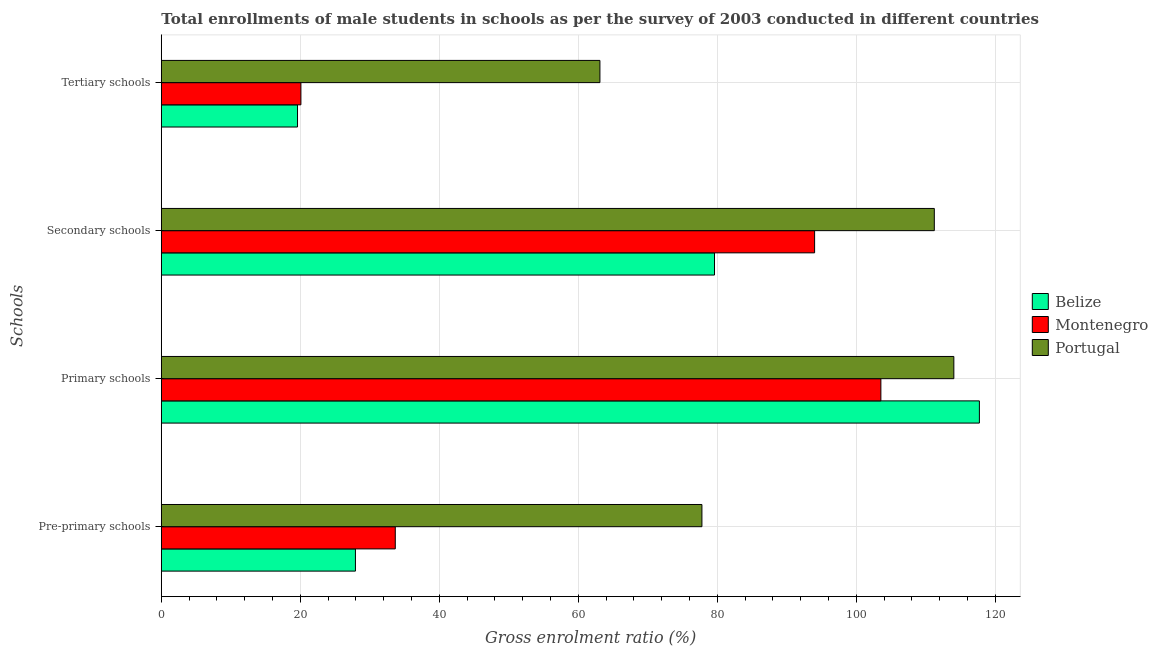Are the number of bars per tick equal to the number of legend labels?
Keep it short and to the point. Yes. How many bars are there on the 3rd tick from the bottom?
Provide a succinct answer. 3. What is the label of the 1st group of bars from the top?
Make the answer very short. Tertiary schools. What is the gross enrolment ratio(male) in pre-primary schools in Montenegro?
Your answer should be very brief. 33.67. Across all countries, what is the maximum gross enrolment ratio(male) in secondary schools?
Provide a succinct answer. 111.24. Across all countries, what is the minimum gross enrolment ratio(male) in primary schools?
Your answer should be compact. 103.55. In which country was the gross enrolment ratio(male) in pre-primary schools minimum?
Your answer should be compact. Belize. What is the total gross enrolment ratio(male) in tertiary schools in the graph?
Ensure brevity in your answer.  102.8. What is the difference between the gross enrolment ratio(male) in secondary schools in Portugal and that in Montenegro?
Your answer should be very brief. 17.22. What is the difference between the gross enrolment ratio(male) in pre-primary schools in Belize and the gross enrolment ratio(male) in primary schools in Montenegro?
Offer a terse response. -75.61. What is the average gross enrolment ratio(male) in secondary schools per country?
Your answer should be compact. 94.95. What is the difference between the gross enrolment ratio(male) in primary schools and gross enrolment ratio(male) in secondary schools in Montenegro?
Provide a succinct answer. 9.54. What is the ratio of the gross enrolment ratio(male) in secondary schools in Belize to that in Montenegro?
Make the answer very short. 0.85. Is the gross enrolment ratio(male) in primary schools in Portugal less than that in Belize?
Your answer should be very brief. Yes. What is the difference between the highest and the second highest gross enrolment ratio(male) in primary schools?
Keep it short and to the point. 3.68. What is the difference between the highest and the lowest gross enrolment ratio(male) in secondary schools?
Keep it short and to the point. 31.63. In how many countries, is the gross enrolment ratio(male) in primary schools greater than the average gross enrolment ratio(male) in primary schools taken over all countries?
Ensure brevity in your answer.  2. Is the sum of the gross enrolment ratio(male) in pre-primary schools in Montenegro and Portugal greater than the maximum gross enrolment ratio(male) in secondary schools across all countries?
Your answer should be compact. Yes. What does the 1st bar from the top in Pre-primary schools represents?
Offer a terse response. Portugal. How many bars are there?
Give a very brief answer. 12. Does the graph contain any zero values?
Provide a succinct answer. No. Where does the legend appear in the graph?
Keep it short and to the point. Center right. How are the legend labels stacked?
Give a very brief answer. Vertical. What is the title of the graph?
Provide a succinct answer. Total enrollments of male students in schools as per the survey of 2003 conducted in different countries. What is the label or title of the X-axis?
Provide a short and direct response. Gross enrolment ratio (%). What is the label or title of the Y-axis?
Offer a very short reply. Schools. What is the Gross enrolment ratio (%) of Belize in Pre-primary schools?
Your response must be concise. 27.94. What is the Gross enrolment ratio (%) in Montenegro in Pre-primary schools?
Provide a short and direct response. 33.67. What is the Gross enrolment ratio (%) of Portugal in Pre-primary schools?
Keep it short and to the point. 77.79. What is the Gross enrolment ratio (%) of Belize in Primary schools?
Make the answer very short. 117.72. What is the Gross enrolment ratio (%) of Montenegro in Primary schools?
Keep it short and to the point. 103.55. What is the Gross enrolment ratio (%) of Portugal in Primary schools?
Offer a very short reply. 114.05. What is the Gross enrolment ratio (%) in Belize in Secondary schools?
Provide a succinct answer. 79.6. What is the Gross enrolment ratio (%) of Montenegro in Secondary schools?
Offer a terse response. 94.01. What is the Gross enrolment ratio (%) in Portugal in Secondary schools?
Your response must be concise. 111.24. What is the Gross enrolment ratio (%) in Belize in Tertiary schools?
Give a very brief answer. 19.6. What is the Gross enrolment ratio (%) of Montenegro in Tertiary schools?
Keep it short and to the point. 20.09. What is the Gross enrolment ratio (%) in Portugal in Tertiary schools?
Your answer should be compact. 63.12. Across all Schools, what is the maximum Gross enrolment ratio (%) in Belize?
Offer a terse response. 117.72. Across all Schools, what is the maximum Gross enrolment ratio (%) in Montenegro?
Give a very brief answer. 103.55. Across all Schools, what is the maximum Gross enrolment ratio (%) in Portugal?
Keep it short and to the point. 114.05. Across all Schools, what is the minimum Gross enrolment ratio (%) of Belize?
Keep it short and to the point. 19.6. Across all Schools, what is the minimum Gross enrolment ratio (%) in Montenegro?
Provide a short and direct response. 20.09. Across all Schools, what is the minimum Gross enrolment ratio (%) of Portugal?
Offer a terse response. 63.12. What is the total Gross enrolment ratio (%) of Belize in the graph?
Provide a short and direct response. 244.86. What is the total Gross enrolment ratio (%) of Montenegro in the graph?
Keep it short and to the point. 251.31. What is the total Gross enrolment ratio (%) of Portugal in the graph?
Make the answer very short. 366.19. What is the difference between the Gross enrolment ratio (%) of Belize in Pre-primary schools and that in Primary schools?
Your answer should be very brief. -89.79. What is the difference between the Gross enrolment ratio (%) in Montenegro in Pre-primary schools and that in Primary schools?
Your answer should be compact. -69.88. What is the difference between the Gross enrolment ratio (%) of Portugal in Pre-primary schools and that in Primary schools?
Your answer should be very brief. -36.25. What is the difference between the Gross enrolment ratio (%) of Belize in Pre-primary schools and that in Secondary schools?
Give a very brief answer. -51.67. What is the difference between the Gross enrolment ratio (%) of Montenegro in Pre-primary schools and that in Secondary schools?
Make the answer very short. -60.34. What is the difference between the Gross enrolment ratio (%) in Portugal in Pre-primary schools and that in Secondary schools?
Keep it short and to the point. -33.44. What is the difference between the Gross enrolment ratio (%) in Belize in Pre-primary schools and that in Tertiary schools?
Ensure brevity in your answer.  8.34. What is the difference between the Gross enrolment ratio (%) of Montenegro in Pre-primary schools and that in Tertiary schools?
Provide a succinct answer. 13.58. What is the difference between the Gross enrolment ratio (%) of Portugal in Pre-primary schools and that in Tertiary schools?
Your response must be concise. 14.68. What is the difference between the Gross enrolment ratio (%) in Belize in Primary schools and that in Secondary schools?
Offer a terse response. 38.12. What is the difference between the Gross enrolment ratio (%) in Montenegro in Primary schools and that in Secondary schools?
Keep it short and to the point. 9.54. What is the difference between the Gross enrolment ratio (%) in Portugal in Primary schools and that in Secondary schools?
Ensure brevity in your answer.  2.81. What is the difference between the Gross enrolment ratio (%) in Belize in Primary schools and that in Tertiary schools?
Give a very brief answer. 98.12. What is the difference between the Gross enrolment ratio (%) of Montenegro in Primary schools and that in Tertiary schools?
Offer a very short reply. 83.46. What is the difference between the Gross enrolment ratio (%) of Portugal in Primary schools and that in Tertiary schools?
Offer a terse response. 50.93. What is the difference between the Gross enrolment ratio (%) in Belize in Secondary schools and that in Tertiary schools?
Ensure brevity in your answer.  60. What is the difference between the Gross enrolment ratio (%) in Montenegro in Secondary schools and that in Tertiary schools?
Offer a very short reply. 73.92. What is the difference between the Gross enrolment ratio (%) in Portugal in Secondary schools and that in Tertiary schools?
Offer a very short reply. 48.12. What is the difference between the Gross enrolment ratio (%) in Belize in Pre-primary schools and the Gross enrolment ratio (%) in Montenegro in Primary schools?
Your response must be concise. -75.61. What is the difference between the Gross enrolment ratio (%) of Belize in Pre-primary schools and the Gross enrolment ratio (%) of Portugal in Primary schools?
Provide a succinct answer. -86.11. What is the difference between the Gross enrolment ratio (%) of Montenegro in Pre-primary schools and the Gross enrolment ratio (%) of Portugal in Primary schools?
Offer a very short reply. -80.38. What is the difference between the Gross enrolment ratio (%) in Belize in Pre-primary schools and the Gross enrolment ratio (%) in Montenegro in Secondary schools?
Offer a very short reply. -66.07. What is the difference between the Gross enrolment ratio (%) of Belize in Pre-primary schools and the Gross enrolment ratio (%) of Portugal in Secondary schools?
Your response must be concise. -83.3. What is the difference between the Gross enrolment ratio (%) in Montenegro in Pre-primary schools and the Gross enrolment ratio (%) in Portugal in Secondary schools?
Keep it short and to the point. -77.57. What is the difference between the Gross enrolment ratio (%) of Belize in Pre-primary schools and the Gross enrolment ratio (%) of Montenegro in Tertiary schools?
Provide a short and direct response. 7.85. What is the difference between the Gross enrolment ratio (%) of Belize in Pre-primary schools and the Gross enrolment ratio (%) of Portugal in Tertiary schools?
Offer a very short reply. -35.18. What is the difference between the Gross enrolment ratio (%) in Montenegro in Pre-primary schools and the Gross enrolment ratio (%) in Portugal in Tertiary schools?
Give a very brief answer. -29.45. What is the difference between the Gross enrolment ratio (%) in Belize in Primary schools and the Gross enrolment ratio (%) in Montenegro in Secondary schools?
Offer a very short reply. 23.71. What is the difference between the Gross enrolment ratio (%) of Belize in Primary schools and the Gross enrolment ratio (%) of Portugal in Secondary schools?
Give a very brief answer. 6.49. What is the difference between the Gross enrolment ratio (%) in Montenegro in Primary schools and the Gross enrolment ratio (%) in Portugal in Secondary schools?
Keep it short and to the point. -7.69. What is the difference between the Gross enrolment ratio (%) in Belize in Primary schools and the Gross enrolment ratio (%) in Montenegro in Tertiary schools?
Offer a very short reply. 97.64. What is the difference between the Gross enrolment ratio (%) in Belize in Primary schools and the Gross enrolment ratio (%) in Portugal in Tertiary schools?
Your answer should be very brief. 54.61. What is the difference between the Gross enrolment ratio (%) of Montenegro in Primary schools and the Gross enrolment ratio (%) of Portugal in Tertiary schools?
Keep it short and to the point. 40.43. What is the difference between the Gross enrolment ratio (%) of Belize in Secondary schools and the Gross enrolment ratio (%) of Montenegro in Tertiary schools?
Your response must be concise. 59.52. What is the difference between the Gross enrolment ratio (%) of Belize in Secondary schools and the Gross enrolment ratio (%) of Portugal in Tertiary schools?
Offer a terse response. 16.49. What is the difference between the Gross enrolment ratio (%) of Montenegro in Secondary schools and the Gross enrolment ratio (%) of Portugal in Tertiary schools?
Give a very brief answer. 30.89. What is the average Gross enrolment ratio (%) of Belize per Schools?
Your answer should be very brief. 61.22. What is the average Gross enrolment ratio (%) in Montenegro per Schools?
Ensure brevity in your answer.  62.83. What is the average Gross enrolment ratio (%) of Portugal per Schools?
Offer a terse response. 91.55. What is the difference between the Gross enrolment ratio (%) in Belize and Gross enrolment ratio (%) in Montenegro in Pre-primary schools?
Keep it short and to the point. -5.73. What is the difference between the Gross enrolment ratio (%) in Belize and Gross enrolment ratio (%) in Portugal in Pre-primary schools?
Keep it short and to the point. -49.86. What is the difference between the Gross enrolment ratio (%) in Montenegro and Gross enrolment ratio (%) in Portugal in Pre-primary schools?
Offer a terse response. -44.12. What is the difference between the Gross enrolment ratio (%) in Belize and Gross enrolment ratio (%) in Montenegro in Primary schools?
Offer a very short reply. 14.18. What is the difference between the Gross enrolment ratio (%) in Belize and Gross enrolment ratio (%) in Portugal in Primary schools?
Your answer should be compact. 3.68. What is the difference between the Gross enrolment ratio (%) of Montenegro and Gross enrolment ratio (%) of Portugal in Primary schools?
Provide a short and direct response. -10.5. What is the difference between the Gross enrolment ratio (%) of Belize and Gross enrolment ratio (%) of Montenegro in Secondary schools?
Your answer should be compact. -14.41. What is the difference between the Gross enrolment ratio (%) in Belize and Gross enrolment ratio (%) in Portugal in Secondary schools?
Make the answer very short. -31.63. What is the difference between the Gross enrolment ratio (%) in Montenegro and Gross enrolment ratio (%) in Portugal in Secondary schools?
Your response must be concise. -17.22. What is the difference between the Gross enrolment ratio (%) in Belize and Gross enrolment ratio (%) in Montenegro in Tertiary schools?
Make the answer very short. -0.49. What is the difference between the Gross enrolment ratio (%) in Belize and Gross enrolment ratio (%) in Portugal in Tertiary schools?
Your answer should be compact. -43.52. What is the difference between the Gross enrolment ratio (%) of Montenegro and Gross enrolment ratio (%) of Portugal in Tertiary schools?
Your answer should be very brief. -43.03. What is the ratio of the Gross enrolment ratio (%) in Belize in Pre-primary schools to that in Primary schools?
Your answer should be compact. 0.24. What is the ratio of the Gross enrolment ratio (%) in Montenegro in Pre-primary schools to that in Primary schools?
Provide a short and direct response. 0.33. What is the ratio of the Gross enrolment ratio (%) in Portugal in Pre-primary schools to that in Primary schools?
Your response must be concise. 0.68. What is the ratio of the Gross enrolment ratio (%) in Belize in Pre-primary schools to that in Secondary schools?
Offer a very short reply. 0.35. What is the ratio of the Gross enrolment ratio (%) of Montenegro in Pre-primary schools to that in Secondary schools?
Offer a very short reply. 0.36. What is the ratio of the Gross enrolment ratio (%) of Portugal in Pre-primary schools to that in Secondary schools?
Your response must be concise. 0.7. What is the ratio of the Gross enrolment ratio (%) in Belize in Pre-primary schools to that in Tertiary schools?
Your response must be concise. 1.43. What is the ratio of the Gross enrolment ratio (%) in Montenegro in Pre-primary schools to that in Tertiary schools?
Make the answer very short. 1.68. What is the ratio of the Gross enrolment ratio (%) of Portugal in Pre-primary schools to that in Tertiary schools?
Make the answer very short. 1.23. What is the ratio of the Gross enrolment ratio (%) in Belize in Primary schools to that in Secondary schools?
Your answer should be compact. 1.48. What is the ratio of the Gross enrolment ratio (%) in Montenegro in Primary schools to that in Secondary schools?
Offer a terse response. 1.1. What is the ratio of the Gross enrolment ratio (%) of Portugal in Primary schools to that in Secondary schools?
Provide a succinct answer. 1.03. What is the ratio of the Gross enrolment ratio (%) in Belize in Primary schools to that in Tertiary schools?
Ensure brevity in your answer.  6.01. What is the ratio of the Gross enrolment ratio (%) in Montenegro in Primary schools to that in Tertiary schools?
Give a very brief answer. 5.15. What is the ratio of the Gross enrolment ratio (%) of Portugal in Primary schools to that in Tertiary schools?
Your response must be concise. 1.81. What is the ratio of the Gross enrolment ratio (%) of Belize in Secondary schools to that in Tertiary schools?
Offer a very short reply. 4.06. What is the ratio of the Gross enrolment ratio (%) in Montenegro in Secondary schools to that in Tertiary schools?
Offer a terse response. 4.68. What is the ratio of the Gross enrolment ratio (%) in Portugal in Secondary schools to that in Tertiary schools?
Make the answer very short. 1.76. What is the difference between the highest and the second highest Gross enrolment ratio (%) in Belize?
Keep it short and to the point. 38.12. What is the difference between the highest and the second highest Gross enrolment ratio (%) in Montenegro?
Offer a very short reply. 9.54. What is the difference between the highest and the second highest Gross enrolment ratio (%) in Portugal?
Provide a short and direct response. 2.81. What is the difference between the highest and the lowest Gross enrolment ratio (%) of Belize?
Make the answer very short. 98.12. What is the difference between the highest and the lowest Gross enrolment ratio (%) in Montenegro?
Keep it short and to the point. 83.46. What is the difference between the highest and the lowest Gross enrolment ratio (%) in Portugal?
Offer a very short reply. 50.93. 